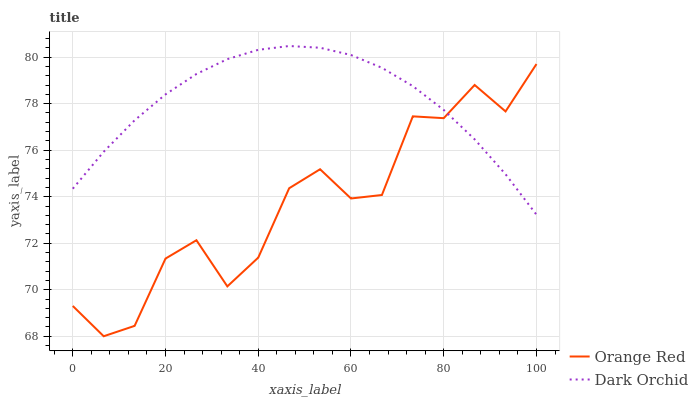Does Orange Red have the minimum area under the curve?
Answer yes or no. Yes. Does Dark Orchid have the maximum area under the curve?
Answer yes or no. Yes. Does Dark Orchid have the minimum area under the curve?
Answer yes or no. No. Is Dark Orchid the smoothest?
Answer yes or no. Yes. Is Orange Red the roughest?
Answer yes or no. Yes. Is Dark Orchid the roughest?
Answer yes or no. No. Does Orange Red have the lowest value?
Answer yes or no. Yes. Does Dark Orchid have the lowest value?
Answer yes or no. No. Does Dark Orchid have the highest value?
Answer yes or no. Yes. Does Orange Red intersect Dark Orchid?
Answer yes or no. Yes. Is Orange Red less than Dark Orchid?
Answer yes or no. No. Is Orange Red greater than Dark Orchid?
Answer yes or no. No. 